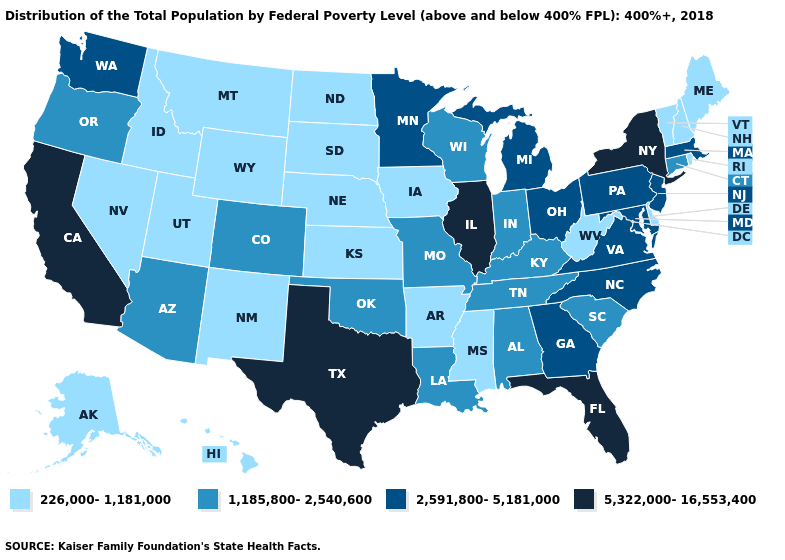Name the states that have a value in the range 2,591,800-5,181,000?
Short answer required. Georgia, Maryland, Massachusetts, Michigan, Minnesota, New Jersey, North Carolina, Ohio, Pennsylvania, Virginia, Washington. What is the value of New Hampshire?
Concise answer only. 226,000-1,181,000. What is the value of South Dakota?
Short answer required. 226,000-1,181,000. What is the highest value in states that border North Carolina?
Be succinct. 2,591,800-5,181,000. Among the states that border South Carolina , which have the highest value?
Be succinct. Georgia, North Carolina. Does the map have missing data?
Quick response, please. No. Does Illinois have the highest value in the MidWest?
Give a very brief answer. Yes. What is the value of Ohio?
Quick response, please. 2,591,800-5,181,000. What is the highest value in the USA?
Give a very brief answer. 5,322,000-16,553,400. What is the value of Missouri?
Answer briefly. 1,185,800-2,540,600. What is the value of South Carolina?
Give a very brief answer. 1,185,800-2,540,600. How many symbols are there in the legend?
Answer briefly. 4. Which states have the highest value in the USA?
Be succinct. California, Florida, Illinois, New York, Texas. What is the lowest value in states that border Maine?
Keep it brief. 226,000-1,181,000. Does Nebraska have the highest value in the USA?
Give a very brief answer. No. 